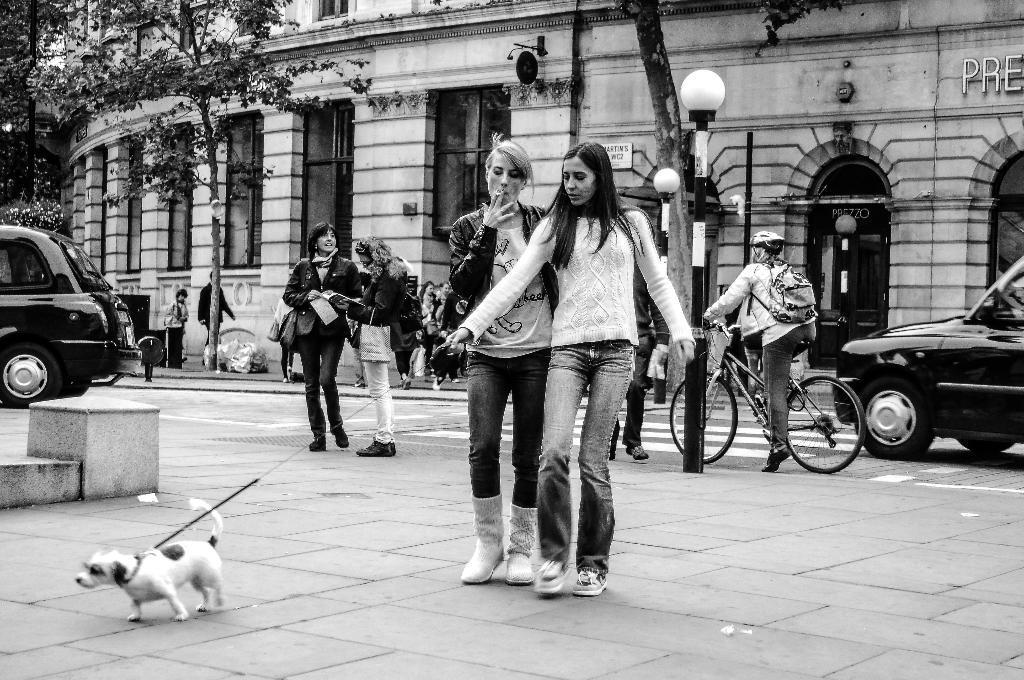In one or two sentences, can you explain what this image depicts? In this image i can see two women standing on the road holding dogs belt,here two women are standing and talking,here the person riding the bicycle,At back ground i can see two cars,a building, a light pole, a plant and few persons walking on the road. 